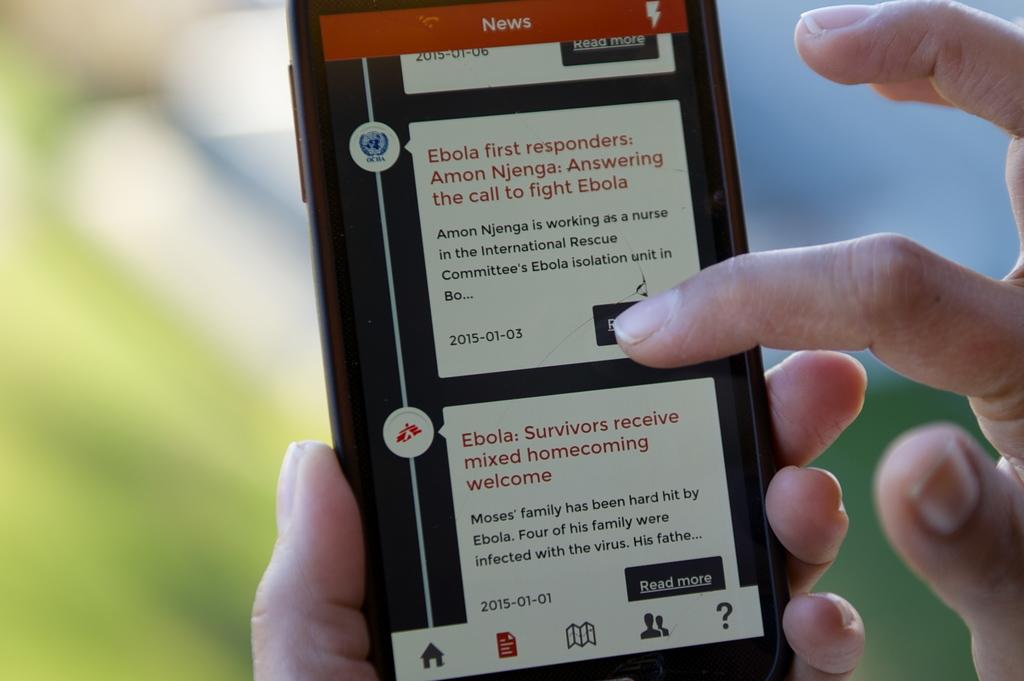What is the black button for?
Keep it short and to the point. Read more. What disease are these news alerts about?
Offer a terse response. Ebola. 